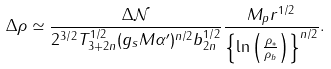<formula> <loc_0><loc_0><loc_500><loc_500>\Delta \rho \simeq \frac { \Delta \mathcal { N } } { 2 ^ { 3 / 2 } T _ { 3 + 2 n } ^ { 1 / 2 } ( g _ { s } M \alpha ^ { \prime } ) ^ { n / 2 } b _ { 2 n } ^ { 1 / 2 } } \frac { M _ { p } r ^ { 1 / 2 } } { \left \{ \ln \left ( \frac { \rho _ { * } } { \rho _ { b } } \right ) \right \} ^ { n / 2 } } .</formula> 